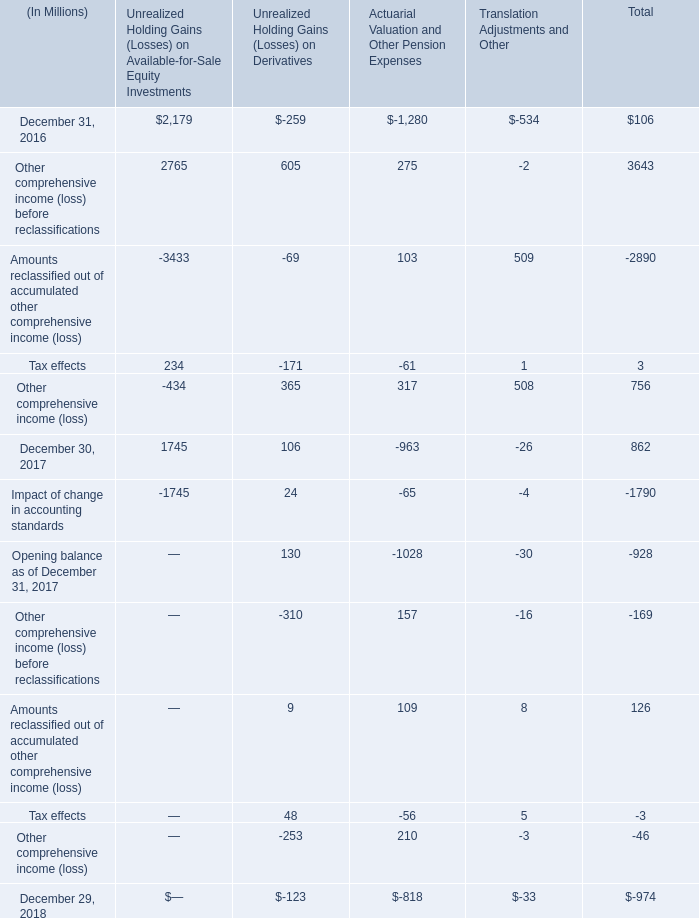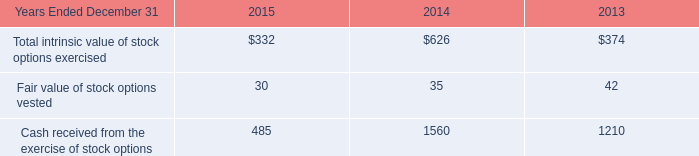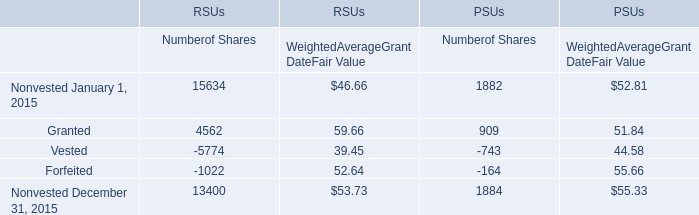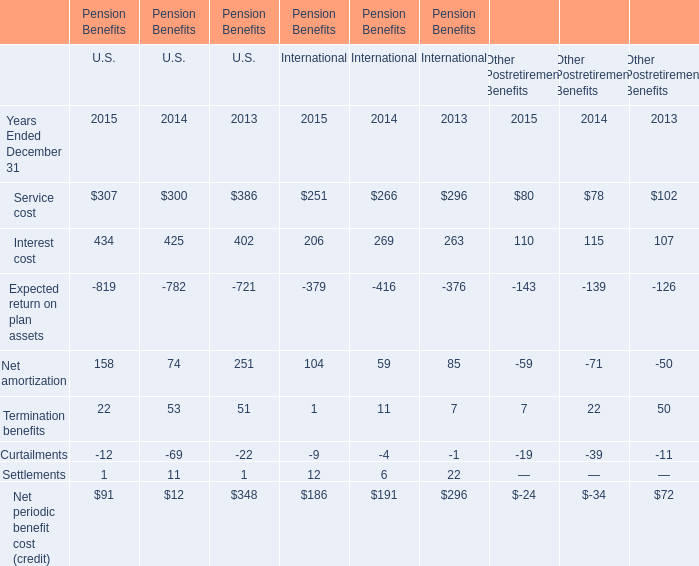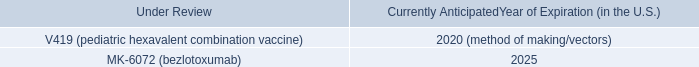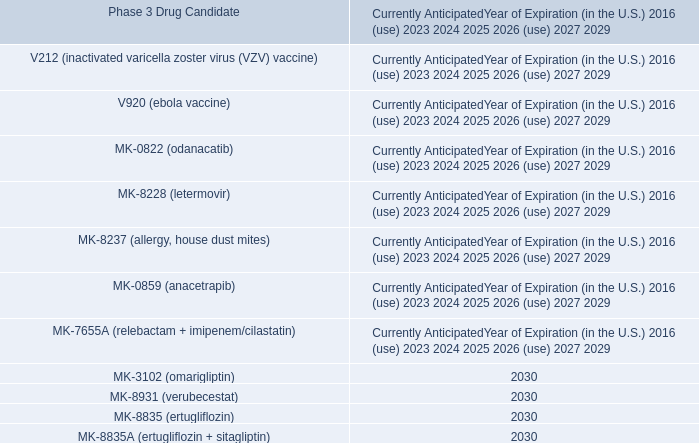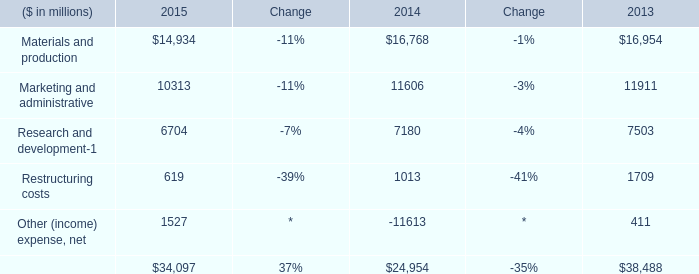In the year with largest amount of Service cost, what's the sum of Interest cost? 
Computations: ((402 + 263) + 107)
Answer: 772.0. 